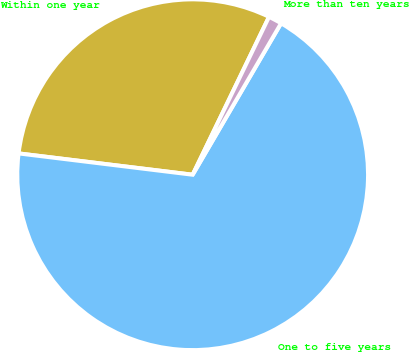<chart> <loc_0><loc_0><loc_500><loc_500><pie_chart><fcel>Within one year<fcel>One to five years<fcel>More than ten years<nl><fcel>30.23%<fcel>68.53%<fcel>1.24%<nl></chart> 